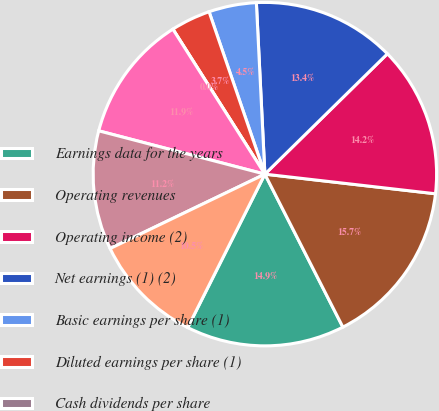<chart> <loc_0><loc_0><loc_500><loc_500><pie_chart><fcel>Earnings data for the years<fcel>Operating revenues<fcel>Operating income (2)<fcel>Net earnings (1) (2)<fcel>Basic earnings per share (1)<fcel>Diluted earnings per share (1)<fcel>Cash dividends per share<fcel>Rents and purchased<fcel>Salaries wages and employee<fcel>Fuel and fuel taxes<nl><fcel>14.92%<fcel>15.67%<fcel>14.18%<fcel>13.43%<fcel>4.48%<fcel>3.73%<fcel>0.0%<fcel>11.94%<fcel>11.19%<fcel>10.45%<nl></chart> 